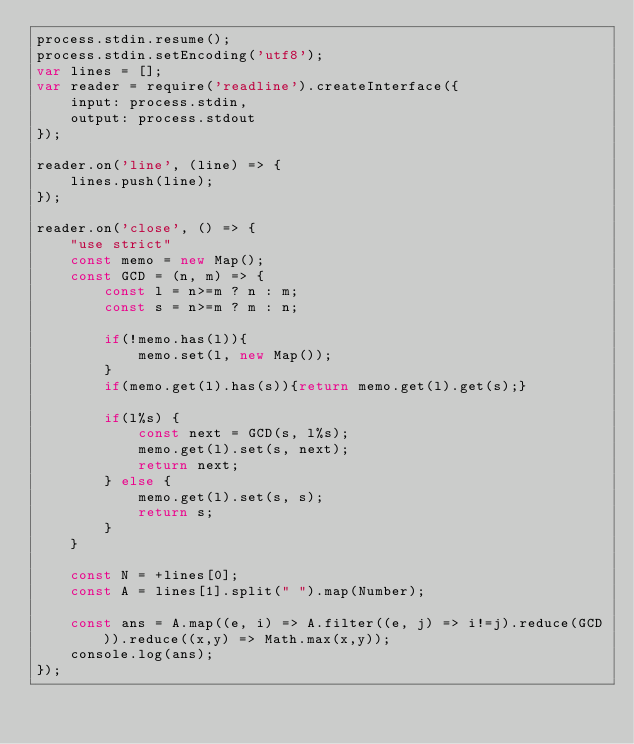Convert code to text. <code><loc_0><loc_0><loc_500><loc_500><_JavaScript_>process.stdin.resume();
process.stdin.setEncoding('utf8'); 
var lines = [];
var reader = require('readline').createInterface({
	input: process.stdin,
	output: process.stdout
});
 
reader.on('line', (line) => {
	lines.push(line);
});

reader.on('close', () => {
	"use strict"
	const memo = new Map();
	const GCD = (n, m) => {
		const l = n>=m ? n : m;
		const s = n>=m ? m : n;
		
		if(!memo.has(l)){
			memo.set(l, new Map());
		}
		if(memo.get(l).has(s)){return memo.get(l).get(s);}
		
		if(l%s) {
			const next = GCD(s, l%s);
			memo.get(l).set(s, next);
			return next;
		} else {
			memo.get(l).set(s, s);
			return s;
		}
	}
	
	const N = +lines[0];
	const A = lines[1].split(" ").map(Number);
	
	const ans = A.map((e, i) => A.filter((e, j) => i!=j).reduce(GCD)).reduce((x,y) => Math.max(x,y));
	console.log(ans);
});

</code> 